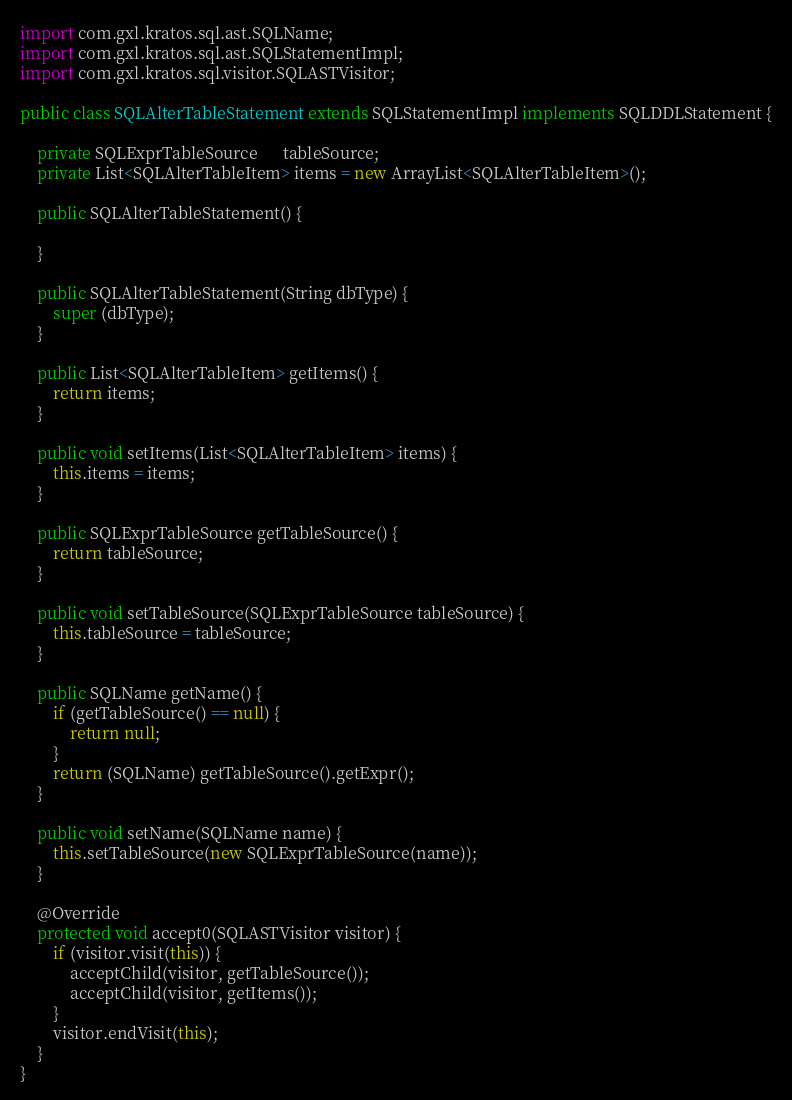<code> <loc_0><loc_0><loc_500><loc_500><_Java_>
import com.gxl.kratos.sql.ast.SQLName;
import com.gxl.kratos.sql.ast.SQLStatementImpl;
import com.gxl.kratos.sql.visitor.SQLASTVisitor;

public class SQLAlterTableStatement extends SQLStatementImpl implements SQLDDLStatement {

    private SQLExprTableSource      tableSource;
    private List<SQLAlterTableItem> items = new ArrayList<SQLAlterTableItem>();
    
    public SQLAlterTableStatement() {
        
    }
    
    public SQLAlterTableStatement(String dbType) {
        super (dbType);
    }

    public List<SQLAlterTableItem> getItems() {
        return items;
    }

    public void setItems(List<SQLAlterTableItem> items) {
        this.items = items;
    }

    public SQLExprTableSource getTableSource() {
        return tableSource;
    }

    public void setTableSource(SQLExprTableSource tableSource) {
        this.tableSource = tableSource;
    }

    public SQLName getName() {
        if (getTableSource() == null) {
            return null;
        }
        return (SQLName) getTableSource().getExpr();
    }

    public void setName(SQLName name) {
        this.setTableSource(new SQLExprTableSource(name));
    }

    @Override
    protected void accept0(SQLASTVisitor visitor) {
        if (visitor.visit(this)) {
            acceptChild(visitor, getTableSource());
            acceptChild(visitor, getItems());
        }
        visitor.endVisit(this);
    }
}
</code> 